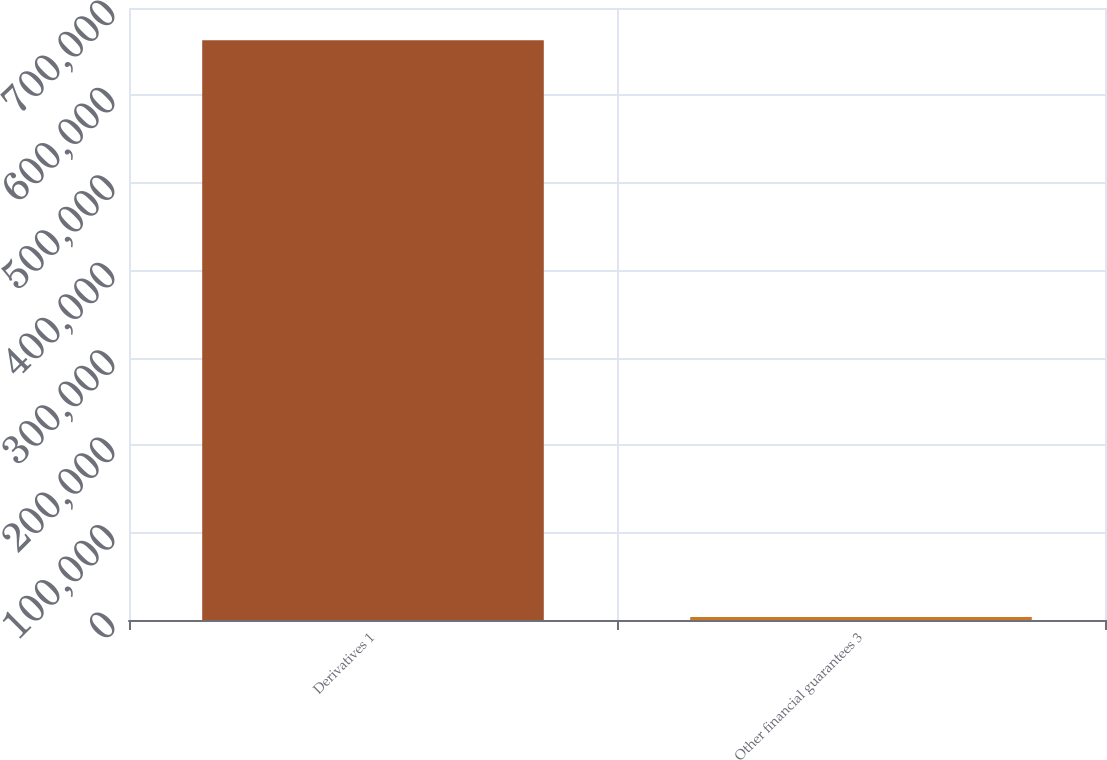Convert chart. <chart><loc_0><loc_0><loc_500><loc_500><bar_chart><fcel>Derivatives 1<fcel>Other financial guarantees 3<nl><fcel>663149<fcel>3479<nl></chart> 